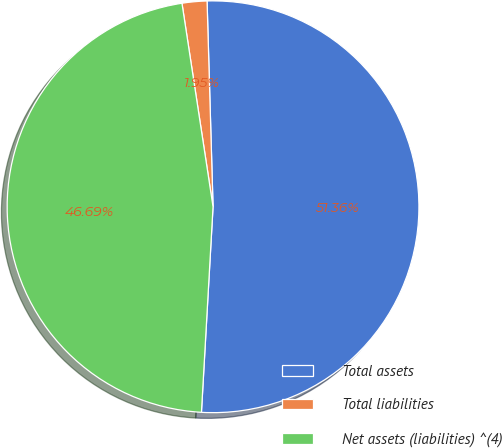Convert chart to OTSL. <chart><loc_0><loc_0><loc_500><loc_500><pie_chart><fcel>Total assets<fcel>Total liabilities<fcel>Net assets (liabilities) ^(4)<nl><fcel>51.36%<fcel>1.95%<fcel>46.69%<nl></chart> 